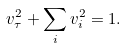<formula> <loc_0><loc_0><loc_500><loc_500>v _ { \tau } ^ { 2 } + \sum _ { i } v _ { i } ^ { 2 } = 1 .</formula> 